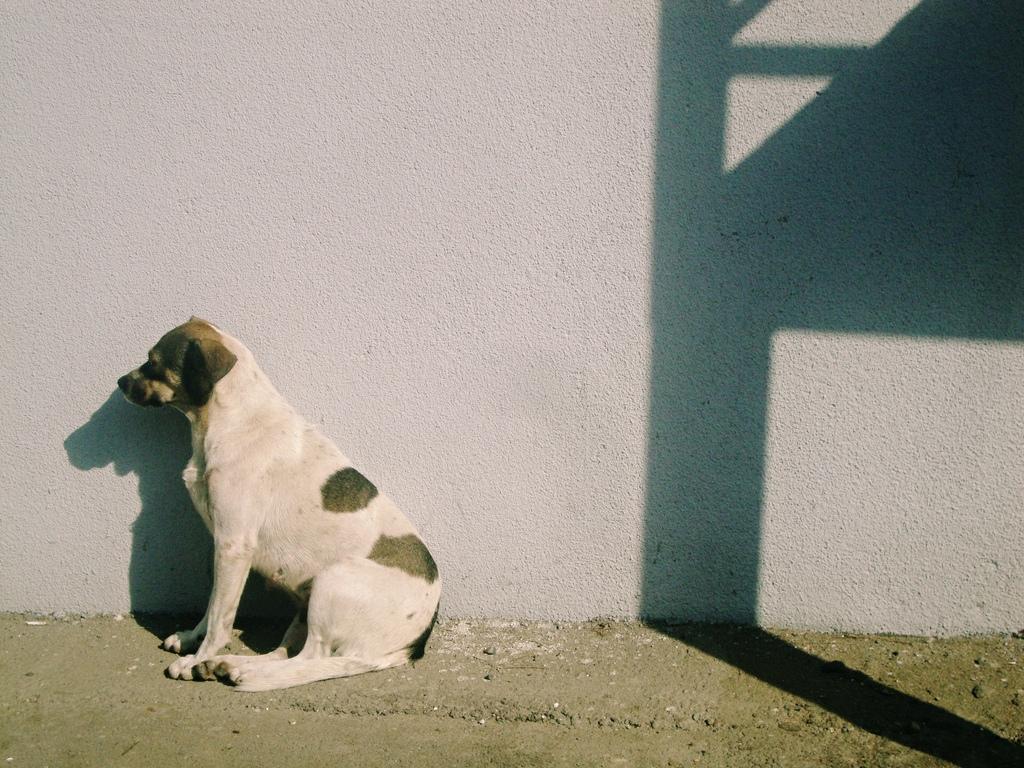In one or two sentences, can you explain what this image depicts? In this picture we can see a dog is sitting. Behind the dog there is the shadow of an object on the wall. 